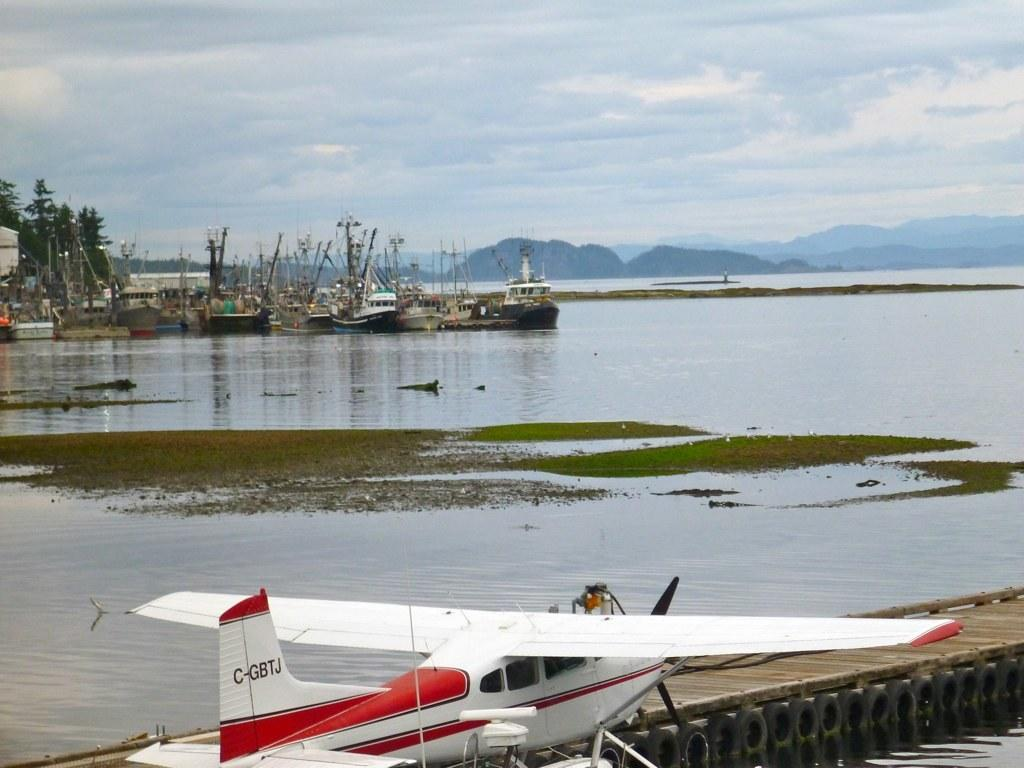What is the primary element in the image? There is water in the image. What activity is taking place in the image? There is a flight in the image. What is located on the deck in the image? There are tires on the deck in the image. What can be seen in the distance in the image? There are many boats, trees, hills, and the sky visible in the background of the image. What statement does the shape in the image make? There is no shape present in the image that could make a statement. 